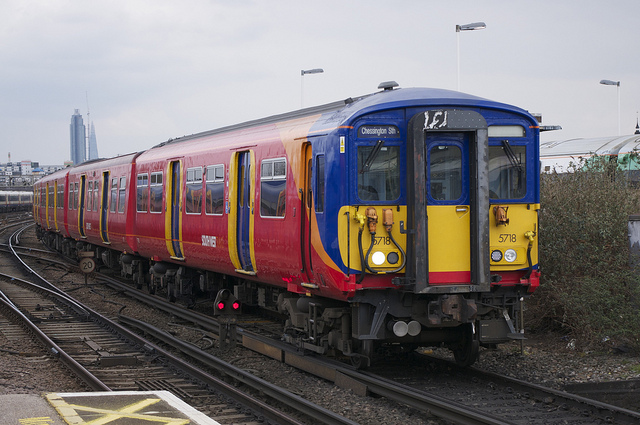Identify and read out the text in this image. 718 5718 